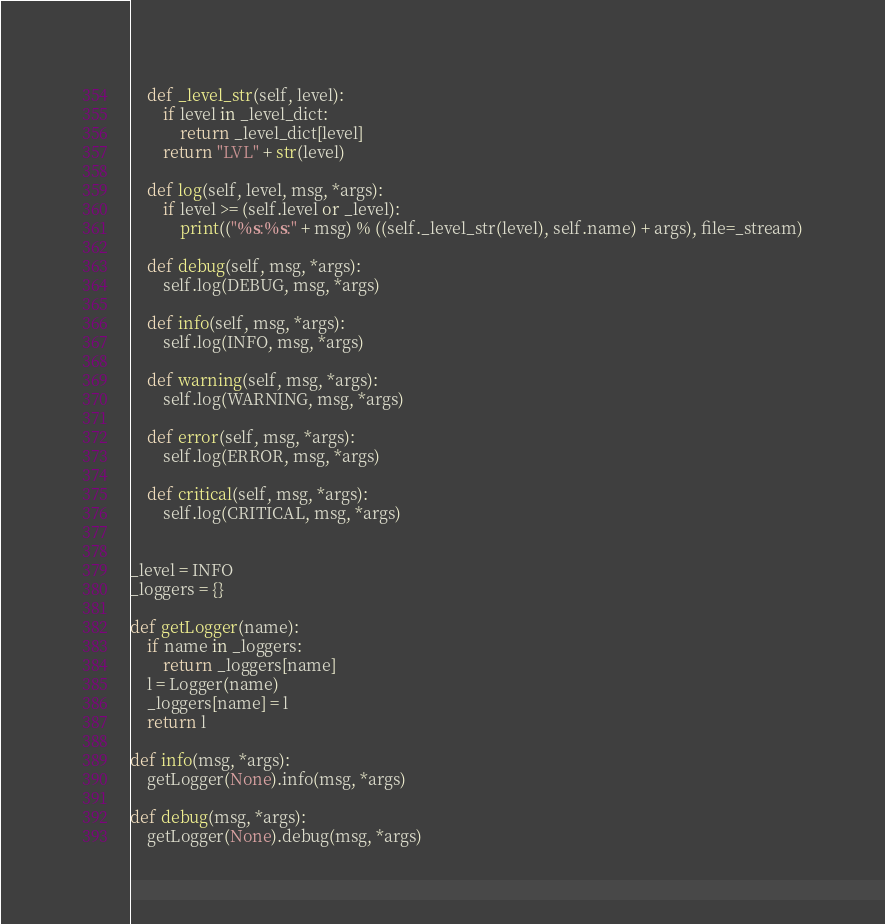<code> <loc_0><loc_0><loc_500><loc_500><_Python_>
    def _level_str(self, level):
        if level in _level_dict:
            return _level_dict[level]
        return "LVL" + str(level)

    def log(self, level, msg, *args):
        if level >= (self.level or _level):
            print(("%s:%s:" + msg) % ((self._level_str(level), self.name) + args), file=_stream)

    def debug(self, msg, *args):
        self.log(DEBUG, msg, *args)

    def info(self, msg, *args):
        self.log(INFO, msg, *args)

    def warning(self, msg, *args):
        self.log(WARNING, msg, *args)

    def error(self, msg, *args):
        self.log(ERROR, msg, *args)

    def critical(self, msg, *args):
        self.log(CRITICAL, msg, *args)


_level = INFO
_loggers = {}

def getLogger(name):
    if name in _loggers:
        return _loggers[name]
    l = Logger(name)
    _loggers[name] = l
    return l

def info(msg, *args):
    getLogger(None).info(msg, *args)

def debug(msg, *args):
    getLogger(None).debug(msg, *args)
</code> 